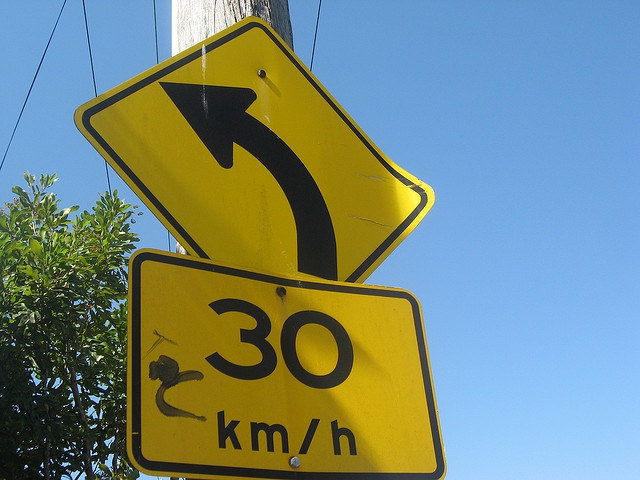Describe the objects in this image and their specific colors. I can see various objects in this image with different colors. 